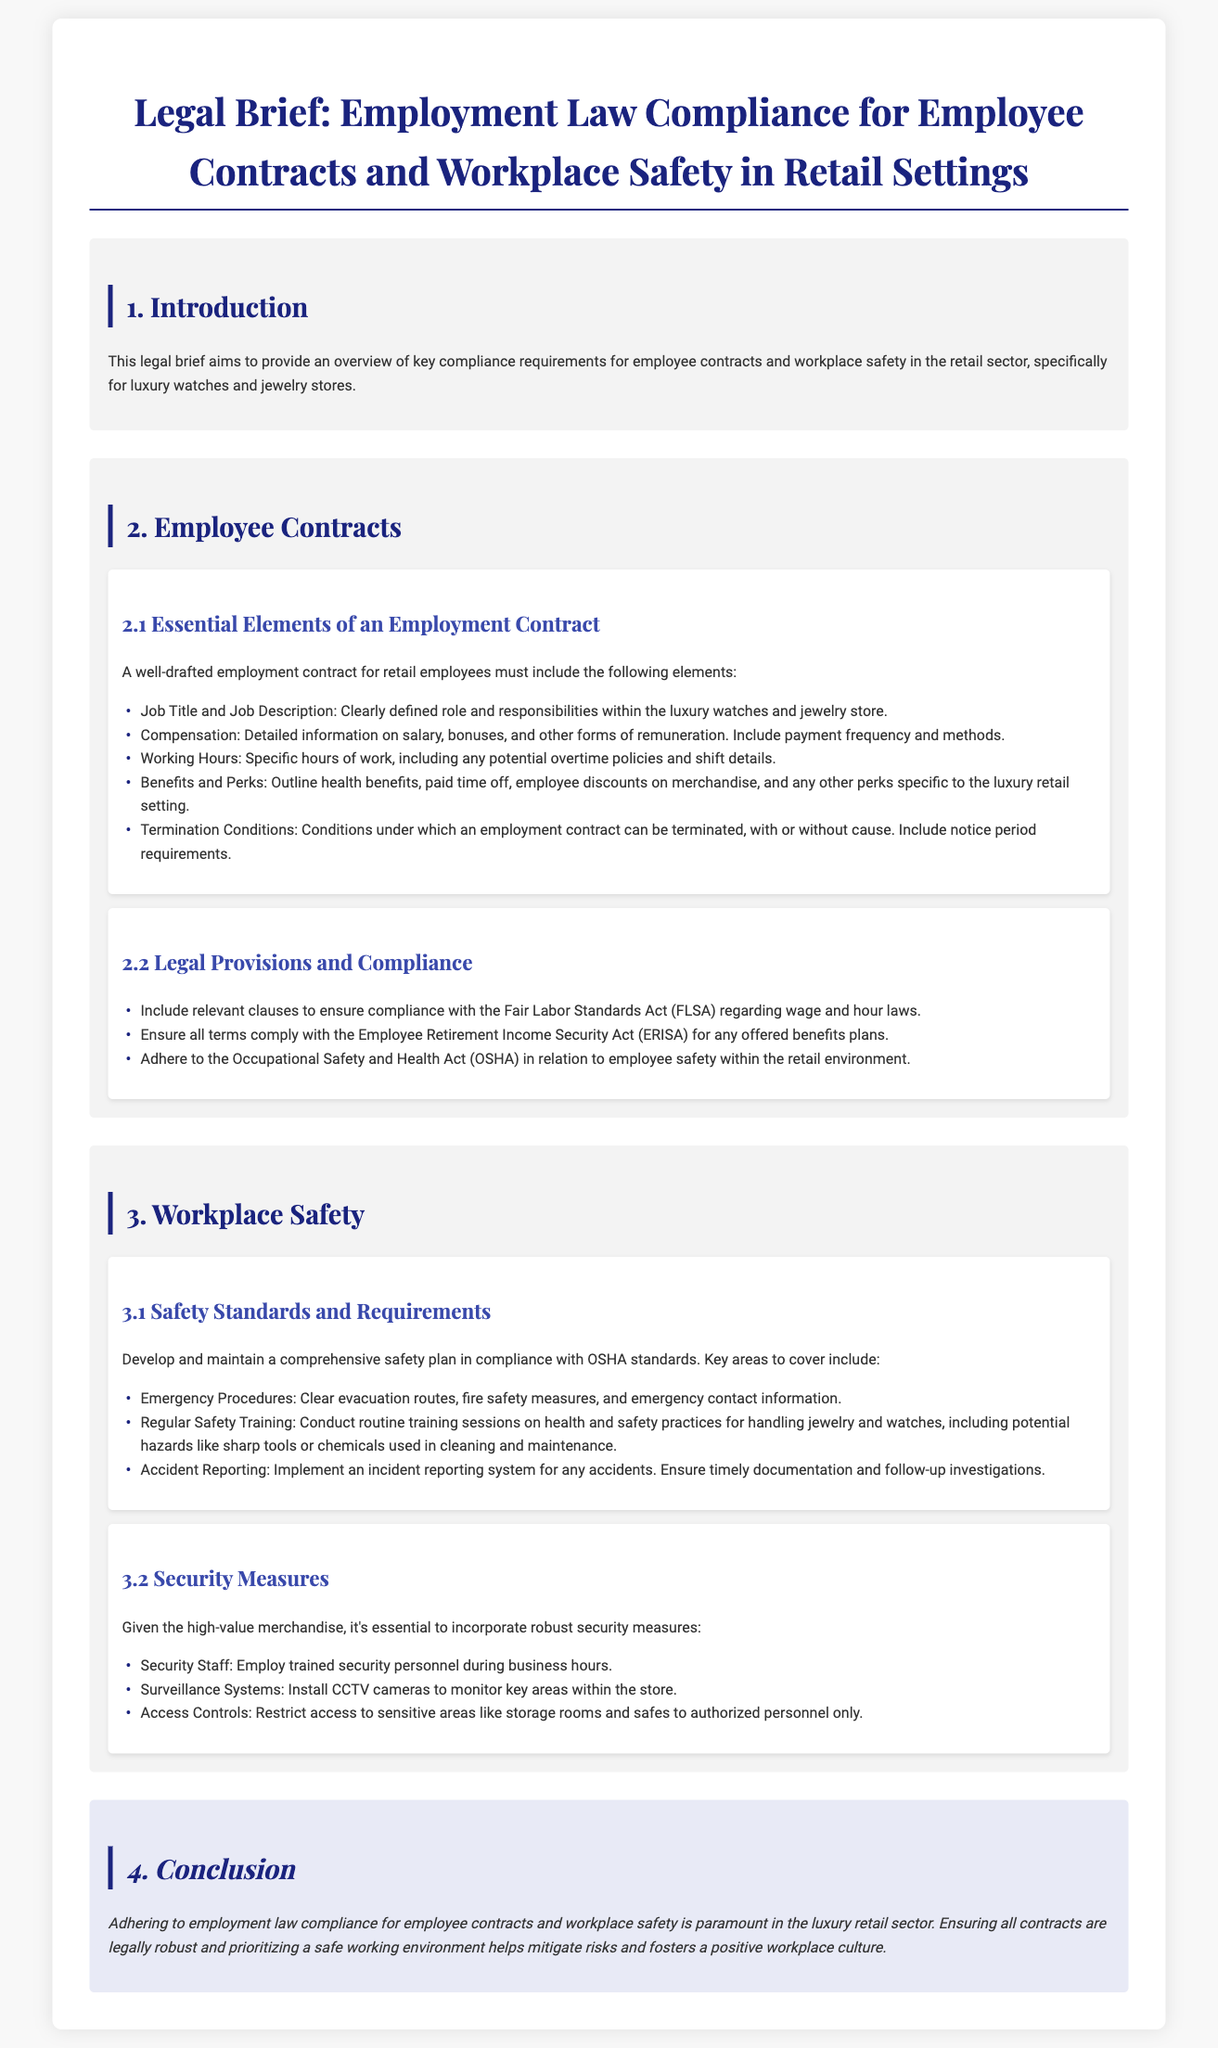What are the essential elements of an employment contract? The essential elements are listed in section 2.1 and include job title, compensation, working hours, benefits, and termination conditions.
Answer: Job Title, Compensation, Working Hours, Benefits, Termination Conditions Which act should employee contracts comply with regarding wage and hour laws? Section 2.2 refers to the Fair Labor Standards Act (FLSA) in relation to wage and hour compliance.
Answer: Fair Labor Standards Act What is included in the safety standards and requirements for retail settings? Section 3.1 outlines safety standards, including emergency procedures, regular safety training, and accident reporting.
Answer: Emergency Procedures, Regular Safety Training, Accident Reporting What type of personnel should be employed during business hours according to the document? Section 3.2 mentions employing trained security personnel as a security measure during business hours.
Answer: Trained Security Personnel What is emphasized as crucial for luxury retail in the conclusion? The conclusion emphasizes the importance of adhering to employment law compliance and prioritizing a safe working environment.
Answer: Adhering to employment law compliance and prioritizing a safe working environment 